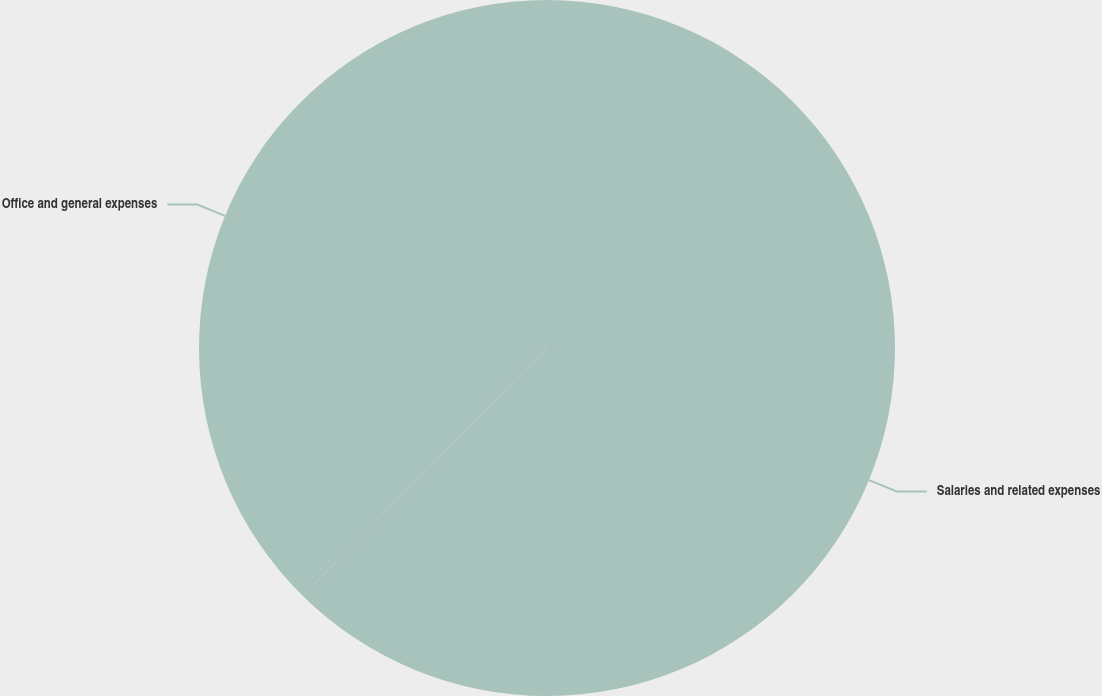Convert chart to OTSL. <chart><loc_0><loc_0><loc_500><loc_500><pie_chart><fcel>Salaries and related expenses<fcel>Office and general expenses<nl><fcel>62.39%<fcel>37.61%<nl></chart> 